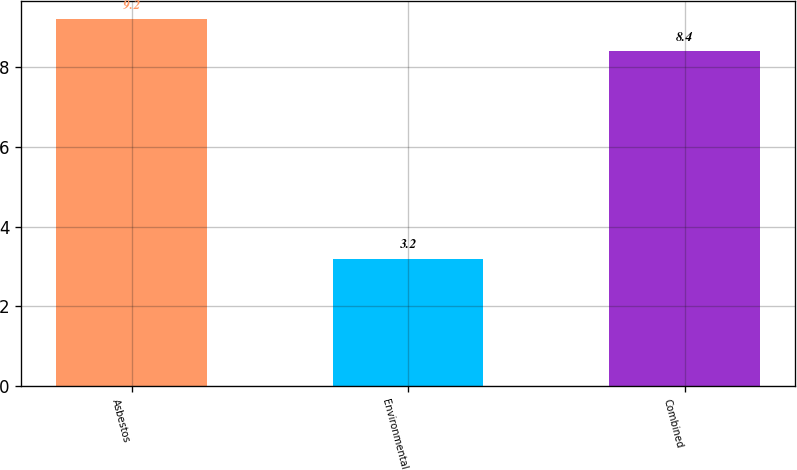Convert chart to OTSL. <chart><loc_0><loc_0><loc_500><loc_500><bar_chart><fcel>Asbestos<fcel>Environmental<fcel>Combined<nl><fcel>9.2<fcel>3.2<fcel>8.4<nl></chart> 